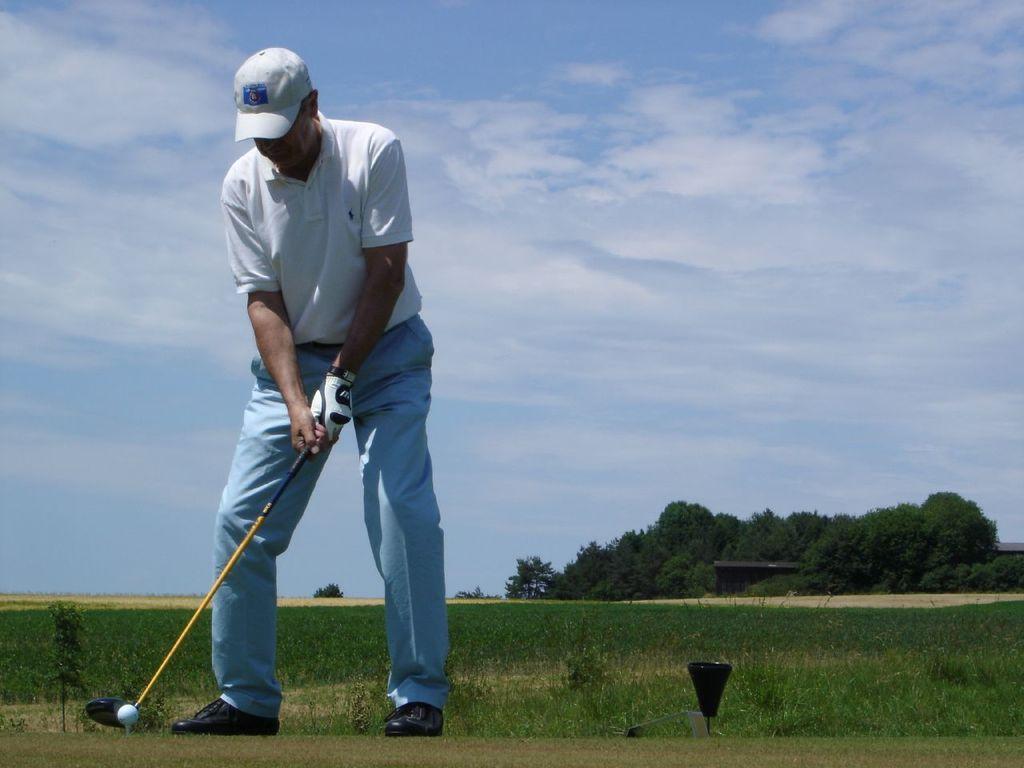In one or two sentences, can you explain what this image depicts? In this image we can see a man wearing the cap and standing and also holding the golf stick. We can also see the ball, grass, trees and also the sky with the clouds in the background. 